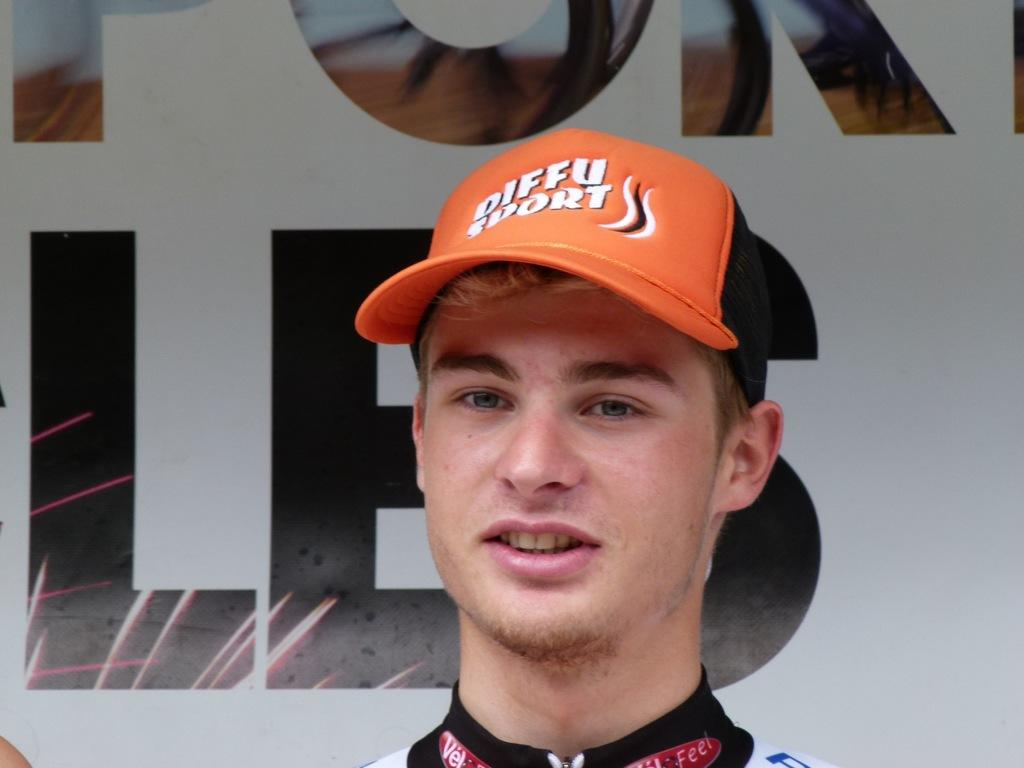<image>
Provide a brief description of the given image. A young man wear an diffu sports orange baseball hat. 